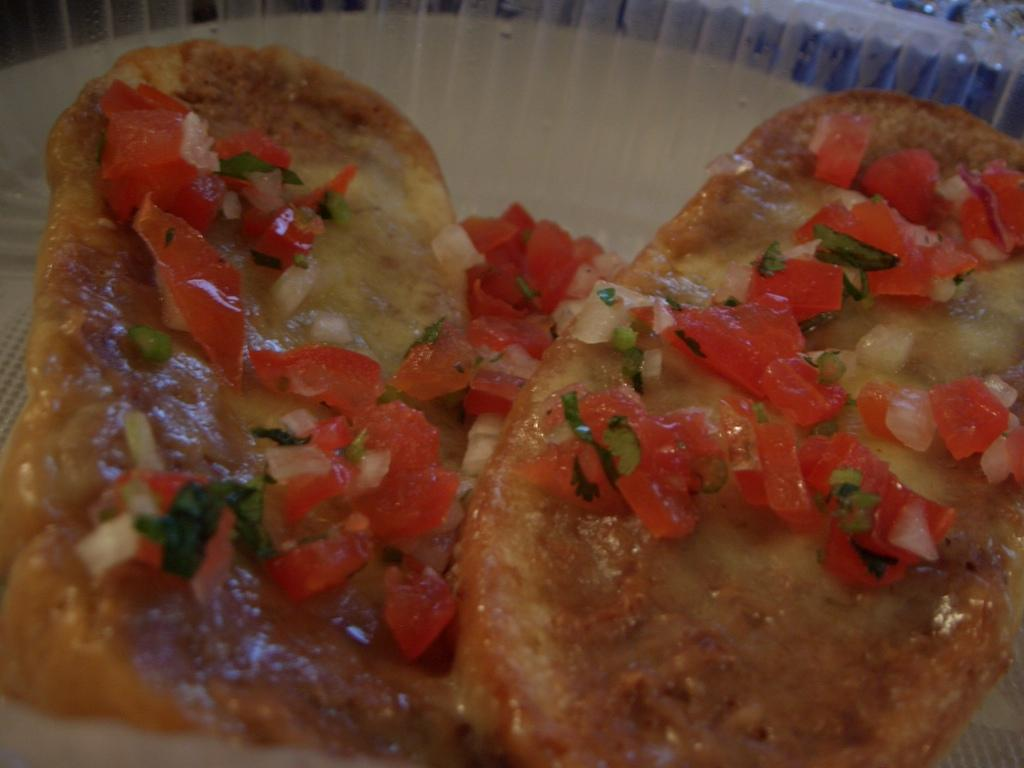What type of food can be seen in the image? There is food in the image, including pieces of onion and tomato. Can you describe the specific ingredients visible in the image? Yes, there are pieces of onion and tomato visible in the image. What type of tank is visible in the image? There is no tank present in the image; it features food with onion and tomato pieces. Is there a party happening in the image? There is no indication of a party in the image; it only shows food with onion and tomato pieces. 